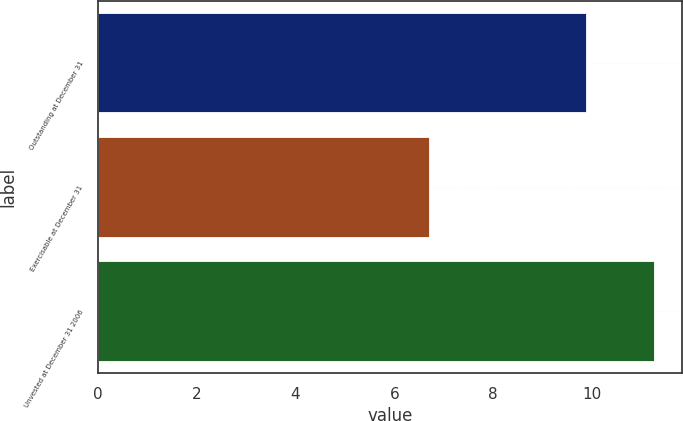<chart> <loc_0><loc_0><loc_500><loc_500><bar_chart><fcel>Outstanding at December 31<fcel>Exercisable at December 31<fcel>Unvested at December 31 2006<nl><fcel>9.87<fcel>6.7<fcel>11.26<nl></chart> 